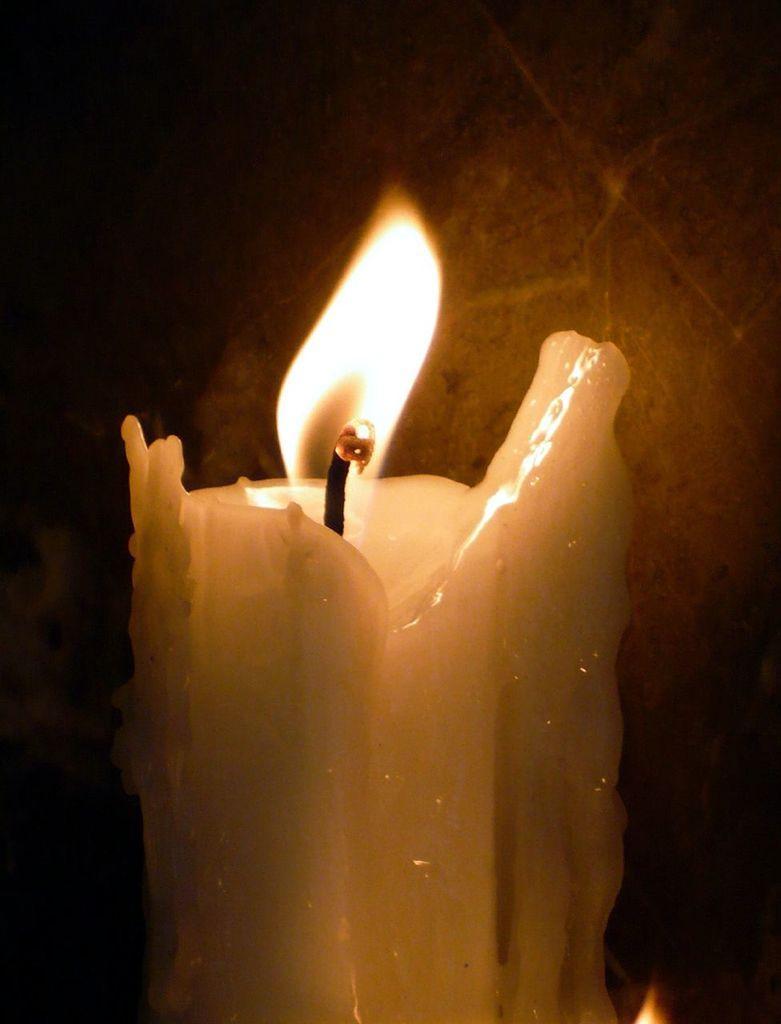How would you summarize this image in a sentence or two? In this picture there is a burning candle in the center of the image. 